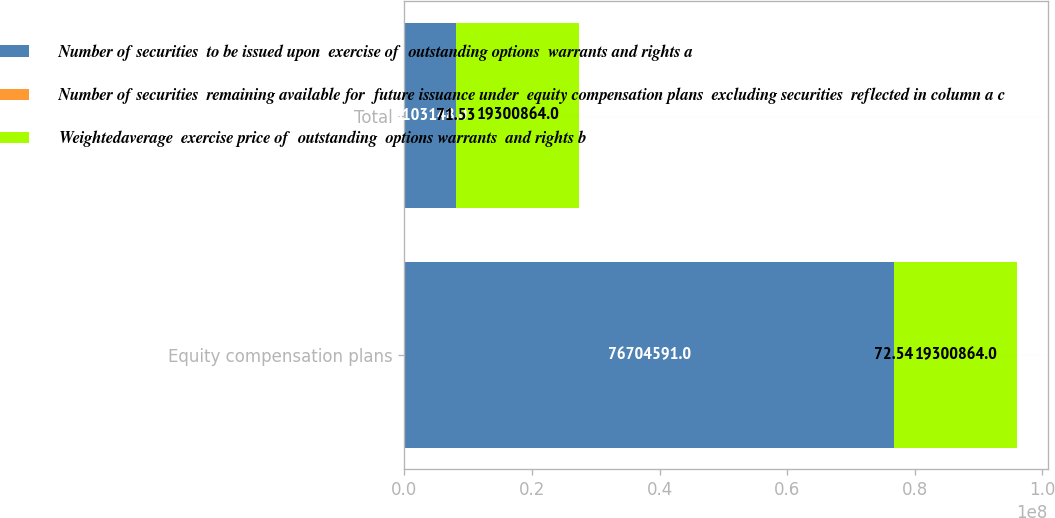<chart> <loc_0><loc_0><loc_500><loc_500><stacked_bar_chart><ecel><fcel>Equity compensation plans<fcel>Total<nl><fcel>Number of securities  to be issued upon  exercise of  outstanding options  warrants and rights a<fcel>7.67046e+07<fcel>8.10315e+06<nl><fcel>Number of securities  remaining available for  future issuance under  equity compensation plans  excluding securities  reflected in column a c<fcel>72.54<fcel>71.53<nl><fcel>Weightedaverage  exercise price of  outstanding  options warrants  and rights b<fcel>1.93009e+07<fcel>1.93009e+07<nl></chart> 